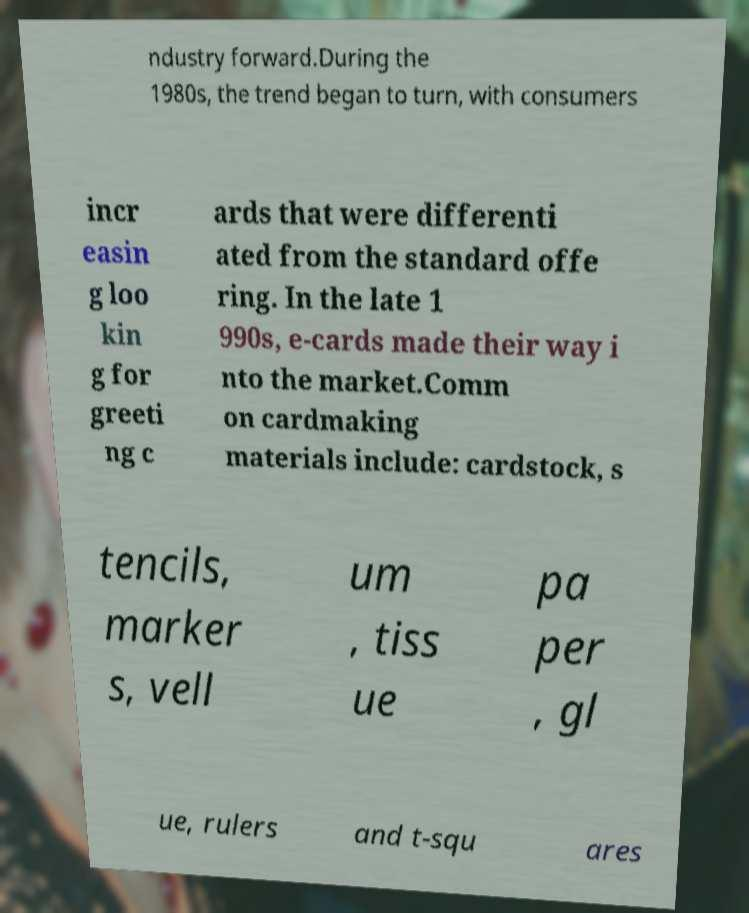Please identify and transcribe the text found in this image. ndustry forward.During the 1980s, the trend began to turn, with consumers incr easin g loo kin g for greeti ng c ards that were differenti ated from the standard offe ring. In the late 1 990s, e-cards made their way i nto the market.Comm on cardmaking materials include: cardstock, s tencils, marker s, vell um , tiss ue pa per , gl ue, rulers and t-squ ares 